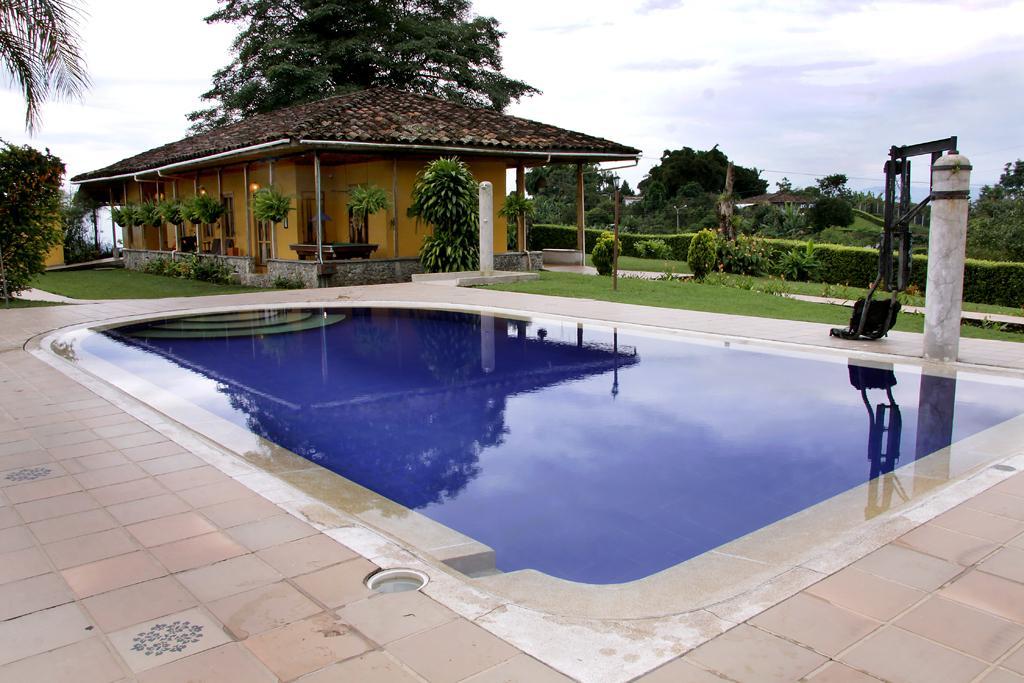Describe this image in one or two sentences. In the picture we can see a swimming pool around it, we can see a path with tiles and behind it, we can see a grass surface and a house with some pillars to it and beside the house also we can see a grass surface and some plants on it and in the background we can see trees and sky with clouds. 